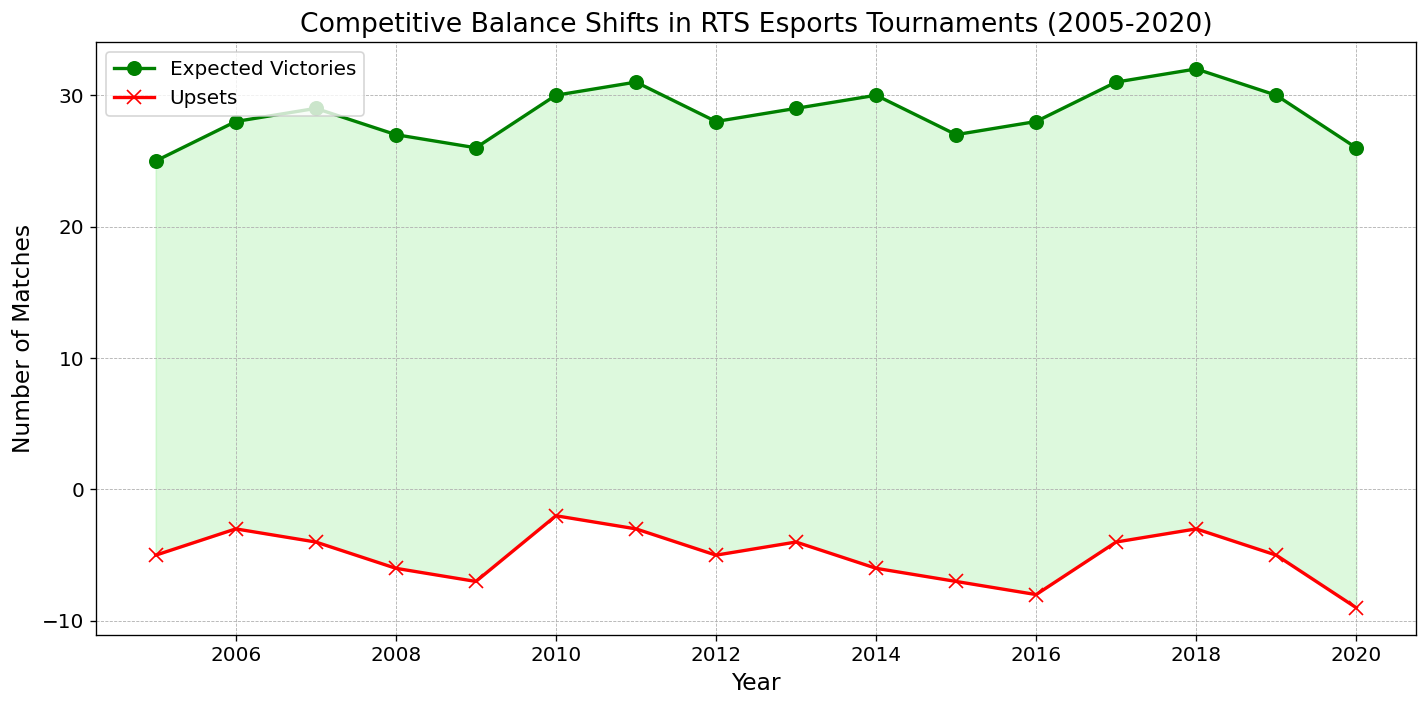What year had the highest number of expected victories? Look at the green line representing expected victories and find the peak point. The highest number of expected victories (32) is in 2018.
Answer: 2018 Which year saw the highest number of upsets? Examine the red line, which indicates upsets. The highest number of upsets (9) occurs in 2020.
Answer: 2020 By how much did the number of expected victories decrease from 2019 to 2020? In 2019, expected victories were 30, and in 2020, they were 26. The decrease is 30 - 26 = 4.
Answer: 4 Which year had a greater number of upsets, 2008 or 2012? Compare the points for upsets for the years 2008 and 2012. In 2008, there were 6 upsets, and in 2012, there were 5.
Answer: 2008 What is the sum of upsets over the period 2015-2017? Sum the upsets for the years 2015, 2016, and 2017. That is 7 + 8 + 4 = 19.
Answer: 19 Was there any year where upsets were higher than expected victories? Compare the green line (expected victories) and the red line (upsets) across all years. No year had upsets higher than expected victories.
Answer: No What trend is visible in the number of expected victories from 2005 to 2011? Observe the green line from 2005 to 2011. The general trend is an increase from 25 in 2005 to 31 in 2011.
Answer: Increase By how much did the number of upsets increase from 2019 to 2020? In 2019, the upsets were 5, and in 2020, they were 9. The increase is 9 - 5 = 4.
Answer: 4 What visual indication shows whether expected victories are greater than upsets or not? Look at the shading between the lines. Light green shading indicates expected victories are greater than upsets; light red shading indicates the opposite.
Answer: Shading color Is there any year where the expected victories and upsets are equal? Check if there is any overlap between the green and red lines. There is no such overlap where they are equal.
Answer: No 